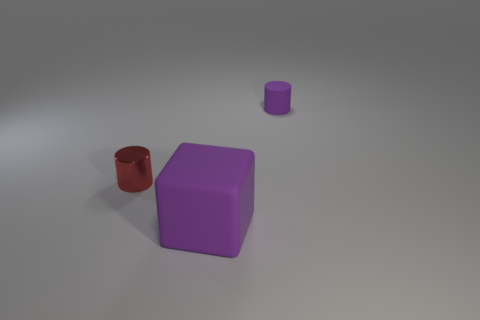Is there anything else that has the same material as the red object?
Give a very brief answer. No. There is a thing that is the same color as the big matte block; what size is it?
Provide a succinct answer. Small. Are there an equal number of tiny red metallic cylinders that are behind the red cylinder and large rubber things?
Keep it short and to the point. No. Are there any other things that are the same size as the cube?
Your answer should be compact. No. The cylinder that is behind the tiny cylinder in front of the matte cylinder is made of what material?
Provide a short and direct response. Rubber. The object that is both right of the small red object and behind the big purple rubber block has what shape?
Offer a terse response. Cylinder. There is a metallic thing that is the same shape as the tiny purple rubber object; what is its size?
Offer a terse response. Small. Are there fewer purple things behind the tiny purple thing than big shiny cylinders?
Provide a succinct answer. No. There is a rubber thing behind the tiny metallic thing; how big is it?
Keep it short and to the point. Small. What is the color of the other thing that is the same shape as the tiny matte thing?
Give a very brief answer. Red. 